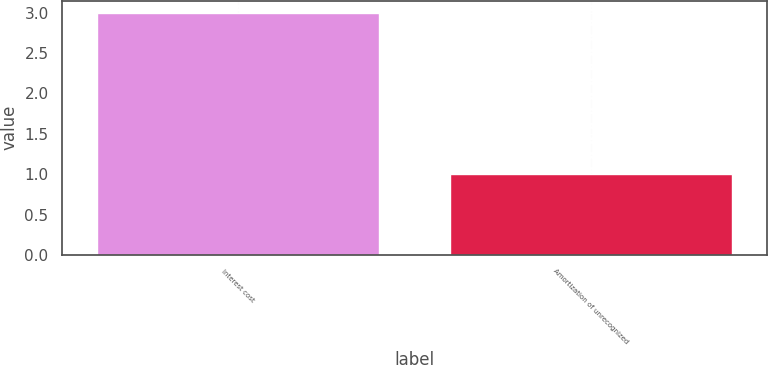Convert chart. <chart><loc_0><loc_0><loc_500><loc_500><bar_chart><fcel>Interest cost<fcel>Amortization of unrecognized<nl><fcel>3<fcel>1<nl></chart> 